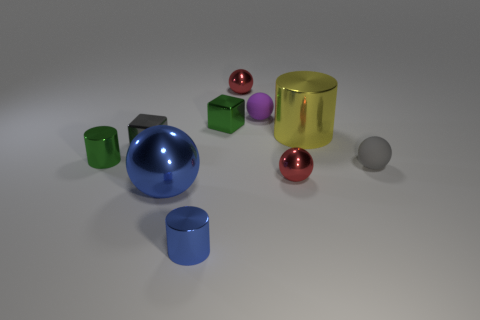Are there any objects of the same color as the big shiny ball?
Provide a succinct answer. Yes. What number of rubber balls are the same size as the green cylinder?
Keep it short and to the point. 2. What number of metal objects are either tiny cylinders or yellow cylinders?
Offer a terse response. 3. What is the size of the metallic cylinder that is the same color as the large shiny sphere?
Make the answer very short. Small. The gray thing on the right side of the tiny matte ball that is behind the yellow shiny thing is made of what material?
Make the answer very short. Rubber. What number of objects are green metal cylinders or small metallic blocks that are behind the gray ball?
Keep it short and to the point. 3. What is the size of the object that is the same material as the purple ball?
Offer a very short reply. Small. What number of blue things are either shiny balls or large balls?
Keep it short and to the point. 1. The thing that is the same color as the big metallic sphere is what shape?
Offer a very short reply. Cylinder. Does the big shiny object left of the purple object have the same shape as the large metallic thing that is behind the tiny gray matte object?
Keep it short and to the point. No. 